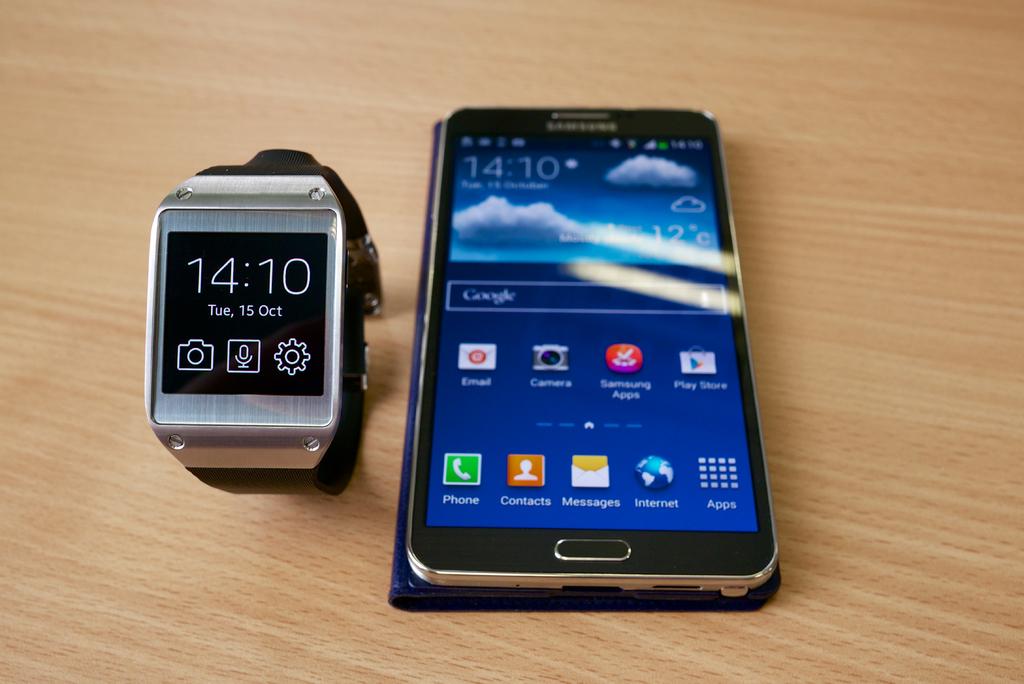What is the time displayed?
Give a very brief answer. 14:10. What is the date?
Your response must be concise. Tue, 15 oct. 